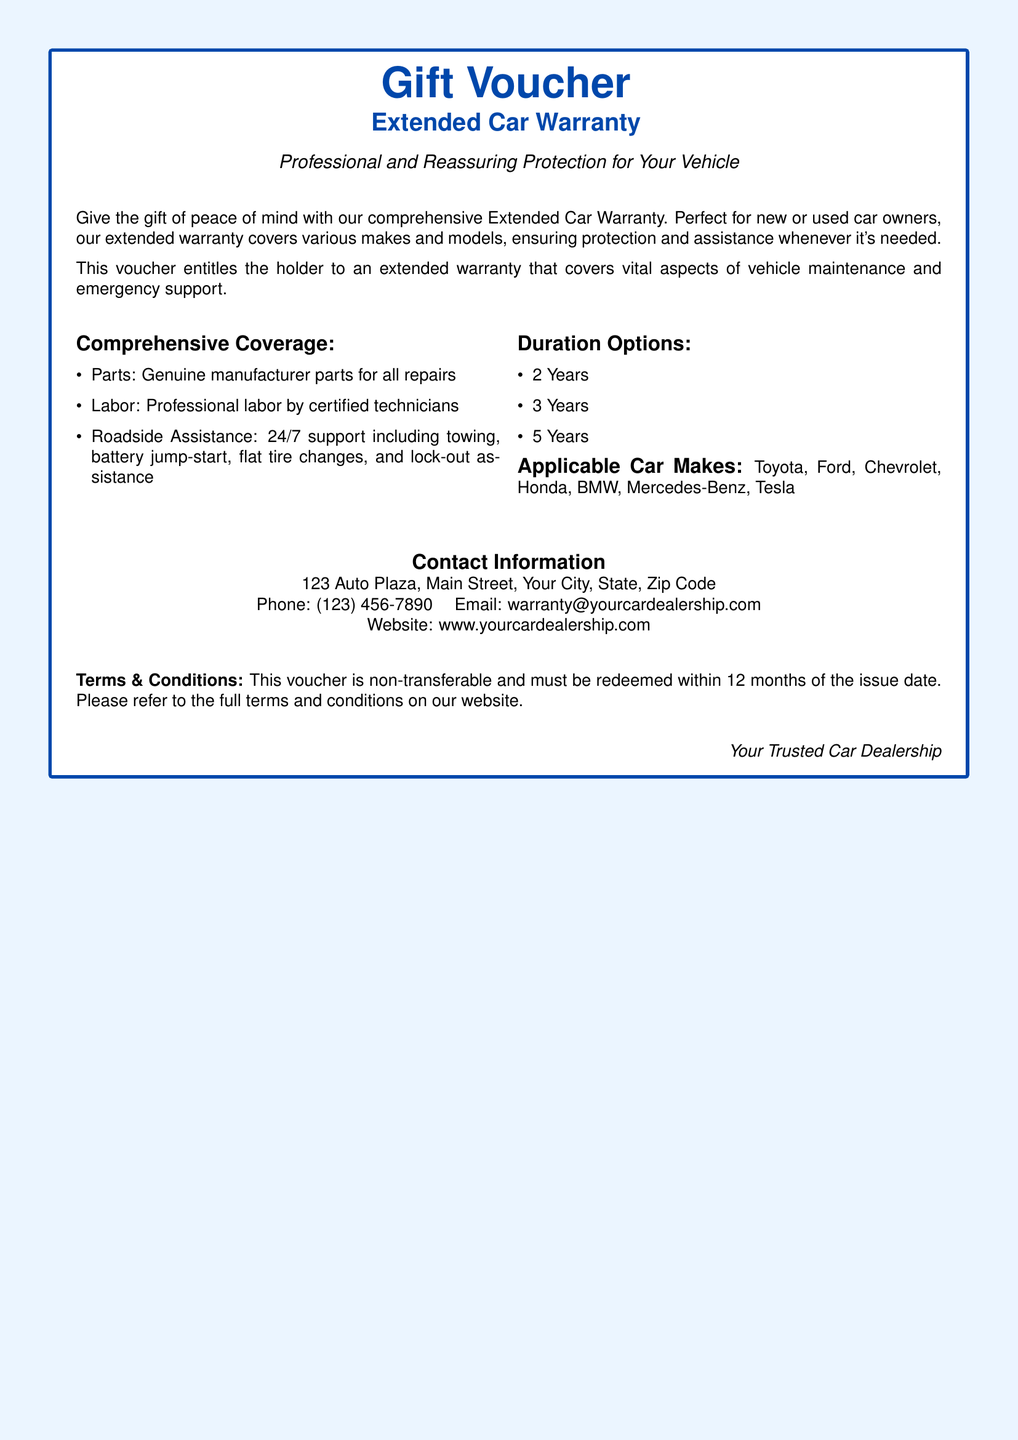What is the title of the voucher? The title of the voucher is prominently displayed at the top of the document.
Answer: Gift Voucher What is covered under the warranty? The document mentions specific items that are included in the warranty coverage.
Answer: Parts, Labor, Roadside Assistance How many duration options are available? The document lists the available duration options for the extended warranty.
Answer: Three Which car makes are mentioned in the document? The document lists applicable car makes, providing specific examples.
Answer: Toyota, Ford, Chevrolet, Honda, BMW, Mercedes-Benz, Tesla What is the contact email for inquiries? The document provides contact information, including an email for customer communication.
Answer: warranty@yourcardealership.com What is the minimum duration option? The document specifies the various duration options available for the warranty.
Answer: 2 Years What is the address of the car dealership? The address is clearly stated in the contact information section of the document.
Answer: 123 Auto Plaza, Main Street, Your City, State, Zip Code What is the main color theme of the document? The color scheme is utilized throughout the document to create a cohesive design.
Answer: Light blue What is the redemption policy for the voucher? The document provides specific terms regarding the use of the voucher, including a time frame.
Answer: 12 months 